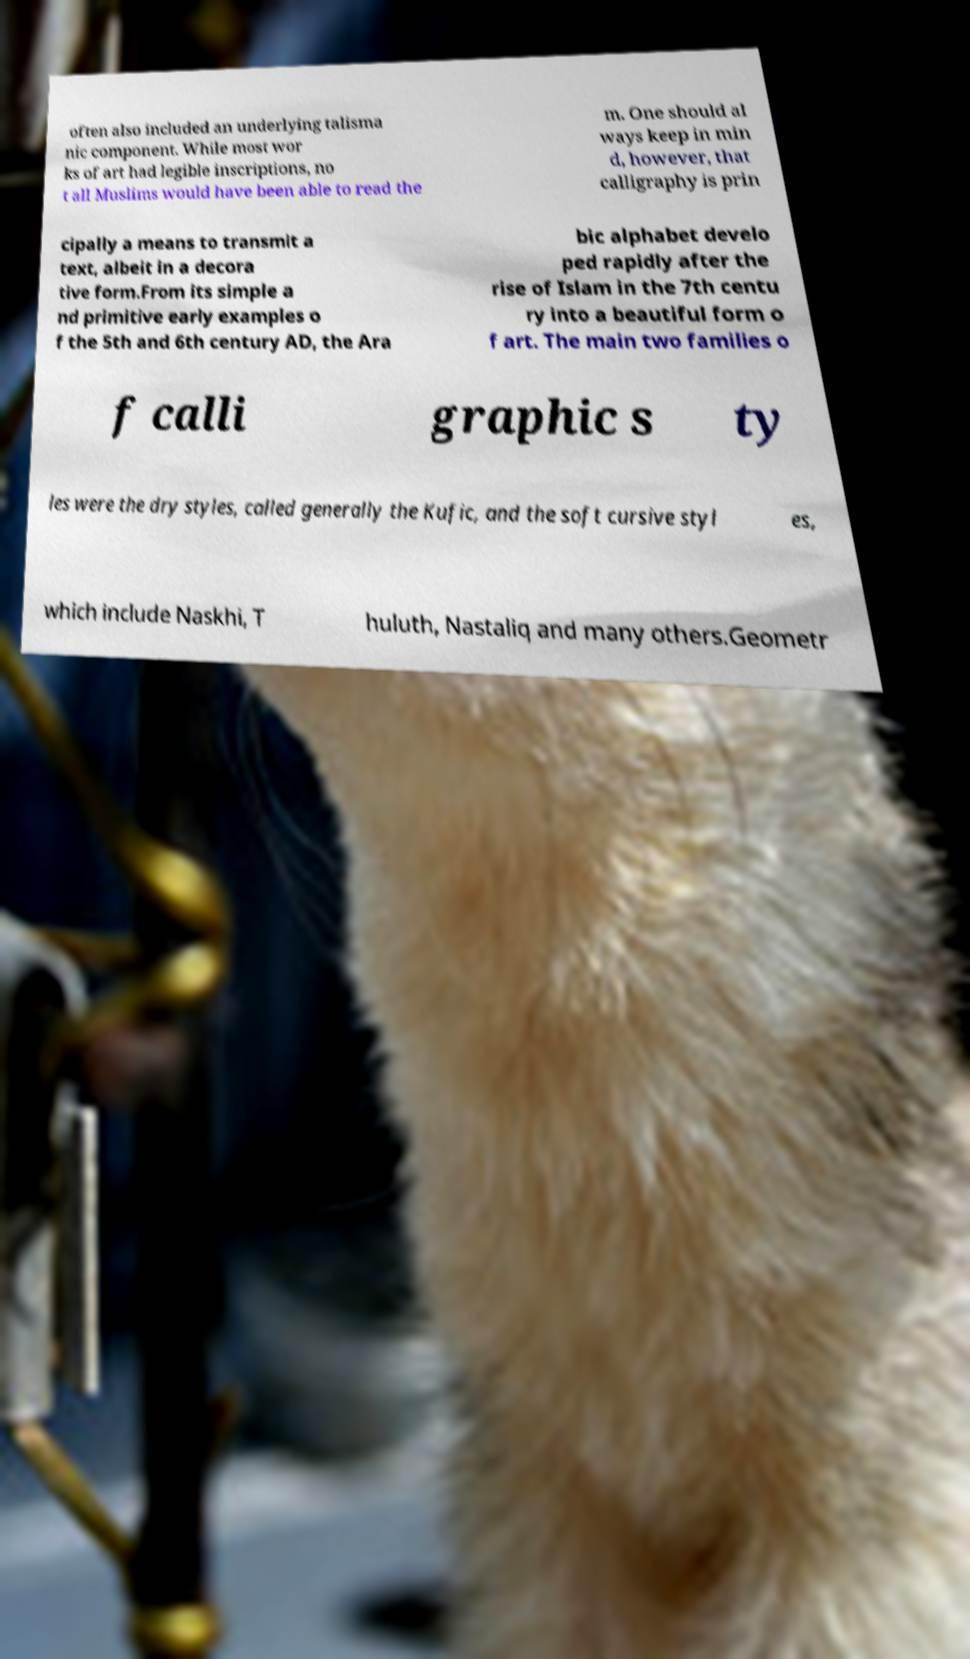I need the written content from this picture converted into text. Can you do that? often also included an underlying talisma nic component. While most wor ks of art had legible inscriptions, no t all Muslims would have been able to read the m. One should al ways keep in min d, however, that calligraphy is prin cipally a means to transmit a text, albeit in a decora tive form.From its simple a nd primitive early examples o f the 5th and 6th century AD, the Ara bic alphabet develo ped rapidly after the rise of Islam in the 7th centu ry into a beautiful form o f art. The main two families o f calli graphic s ty les were the dry styles, called generally the Kufic, and the soft cursive styl es, which include Naskhi, T huluth, Nastaliq and many others.Geometr 